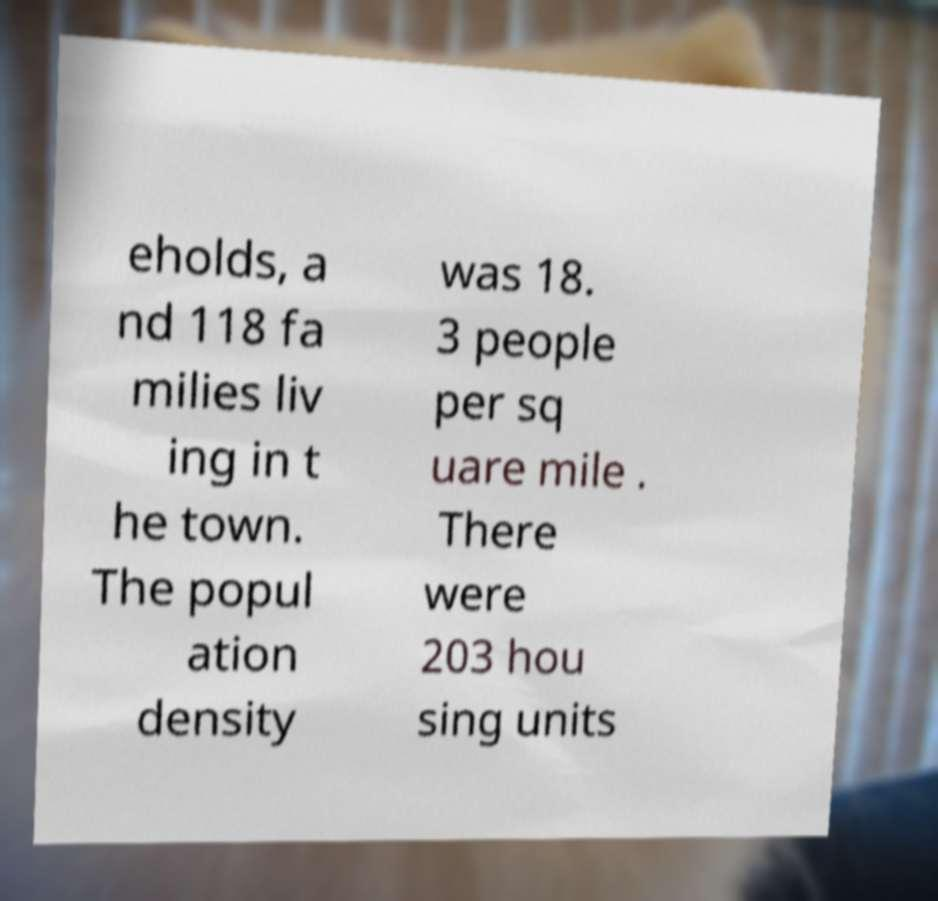I need the written content from this picture converted into text. Can you do that? eholds, a nd 118 fa milies liv ing in t he town. The popul ation density was 18. 3 people per sq uare mile . There were 203 hou sing units 